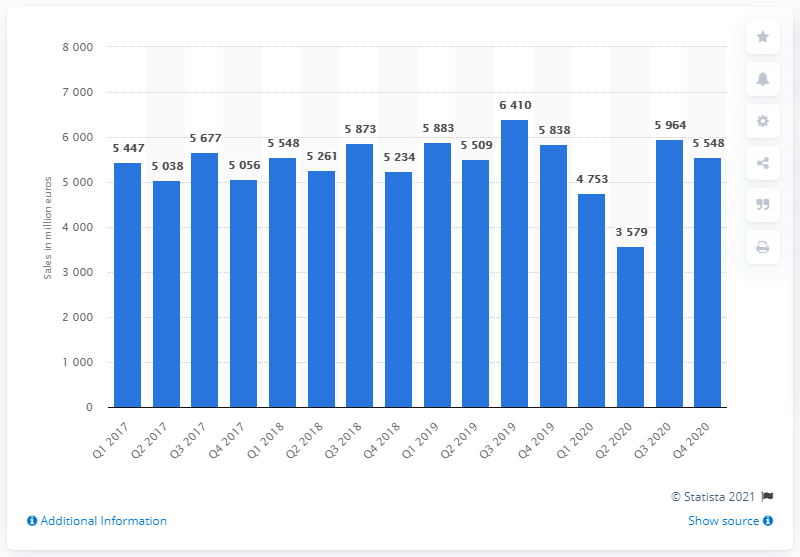Mention a couple of crucial points in this snapshot. In quarter 4 of 2020, the net sales of the adidas Group were 5,548. 